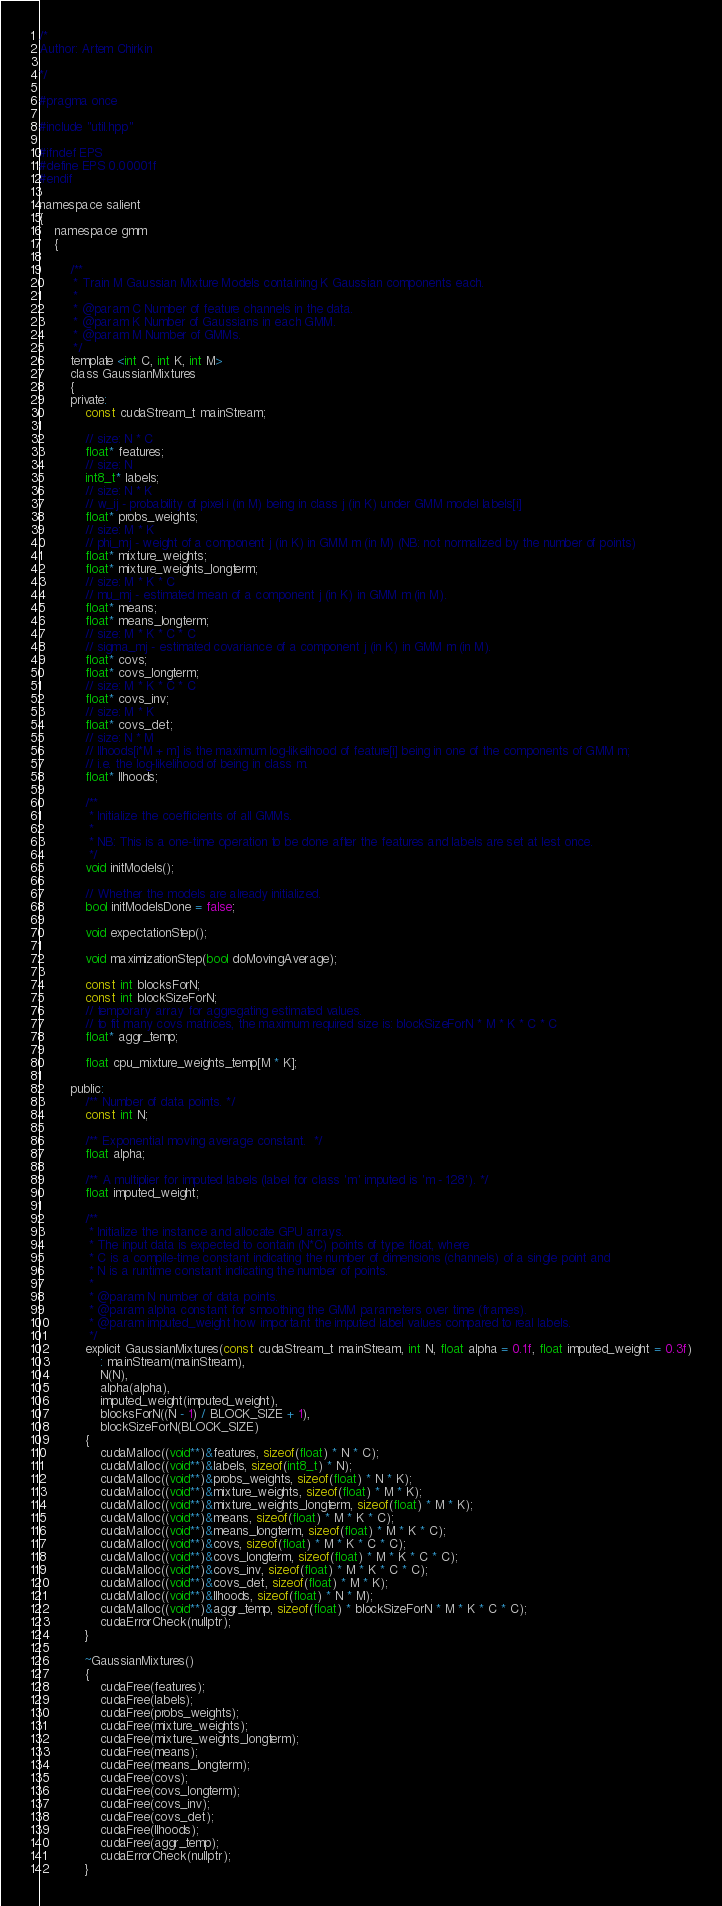<code> <loc_0><loc_0><loc_500><loc_500><_Cuda_>/*
Author: Artem Chirkin

*/

#pragma once

#include "util.hpp"

#ifndef EPS
#define EPS 0.00001f
#endif

namespace salient
{
    namespace gmm
    {

        /**
         * Train M Gaussian Mixture Models containing K Gaussian components each.
         *
         * @param C Number of feature channels in the data.
         * @param K Number of Gaussians in each GMM.
         * @param M Number of GMMs.
         */
        template <int C, int K, int M>
        class GaussianMixtures
        {
        private:
            const cudaStream_t mainStream;

            // size: N * C
            float* features;
            // size: N
            int8_t* labels;
            // size: N * K
            // w_ij - probability of pixel i (in M) being in class j (in K) under GMM model labels[i]
            float* probs_weights;
            // size: M * K
            // phi_mj - weight of a component j (in K) in GMM m (in M) (NB: not normalized by the number of points)
            float* mixture_weights;
            float* mixture_weights_longterm;
            // size: M * K * C
            // mu_mj - estimated mean of a component j (in K) in GMM m (in M).
            float* means;
            float* means_longterm;
            // size: M * K * C * C
            // sigma_mj - estimated covariance of a component j (in K) in GMM m (in M).
            float* covs;
            float* covs_longterm;
            // size: M * K * C * C
            float* covs_inv;
            // size: M * K
            float* covs_det;
            // size: N * M
            // llhoods[i*M + m] is the maximum log-likelihood of feature[i] being in one of the components of GMM m;
            // i.e. the log-likelihood of being in class m.
            float* llhoods;

            /**
             * Initialize the coefficients of all GMMs.
             *
             * NB: This is a one-time operation to be done after the features and labels are set at lest once.
             */
            void initModels();

            // Whether the models are already initialized.
            bool initModelsDone = false;

            void expectationStep();

            void maximizationStep(bool doMovingAverage);

            const int blocksForN;
            const int blockSizeForN;
            // temporary array for aggregating estimated values.
            // to fit many covs matrices, the maximum required size is: blockSizeForN * M * K * C * C
            float* aggr_temp;

            float cpu_mixture_weights_temp[M * K];

        public:
            /** Number of data points. */
            const int N;

            /** Exponential moving average constant.  */
            float alpha;

            /** A multiplier for imputed labels (label for class 'm' imputed is 'm - 128'). */
            float imputed_weight;

            /**
             * Initialize the instance and allocate GPU arrays.
             * The input data is expected to contain (N*C) points of type float, where
             * C is a compile-time constant indicating the number of dimensions (channels) of a single point and
             * N is a runtime constant indicating the number of points.
             *
             * @param N number of data points.
             * @param alpha constant for smoothing the GMM parameters over time (frames).
             * @param imputed_weight how important the imputed label values compared to real labels.
             */
            explicit GaussianMixtures(const cudaStream_t mainStream, int N, float alpha = 0.1f, float imputed_weight = 0.3f)
                : mainStream(mainStream),
                N(N),
                alpha(alpha),
                imputed_weight(imputed_weight),
                blocksForN((N - 1) / BLOCK_SIZE + 1),
                blockSizeForN(BLOCK_SIZE)
            {
                cudaMalloc((void**)&features, sizeof(float) * N * C);
                cudaMalloc((void**)&labels, sizeof(int8_t) * N);
                cudaMalloc((void**)&probs_weights, sizeof(float) * N * K);
                cudaMalloc((void**)&mixture_weights, sizeof(float) * M * K);
                cudaMalloc((void**)&mixture_weights_longterm, sizeof(float) * M * K);
                cudaMalloc((void**)&means, sizeof(float) * M * K * C);
                cudaMalloc((void**)&means_longterm, sizeof(float) * M * K * C);
                cudaMalloc((void**)&covs, sizeof(float) * M * K * C * C);
                cudaMalloc((void**)&covs_longterm, sizeof(float) * M * K * C * C);
                cudaMalloc((void**)&covs_inv, sizeof(float) * M * K * C * C);
                cudaMalloc((void**)&covs_det, sizeof(float) * M * K);
                cudaMalloc((void**)&llhoods, sizeof(float) * N * M);
                cudaMalloc((void**)&aggr_temp, sizeof(float) * blockSizeForN * M * K * C * C);
                cudaErrorCheck(nullptr);
            }

            ~GaussianMixtures()
            {
                cudaFree(features);
                cudaFree(labels);
                cudaFree(probs_weights);
                cudaFree(mixture_weights);
                cudaFree(mixture_weights_longterm);
                cudaFree(means);
                cudaFree(means_longterm);
                cudaFree(covs);
                cudaFree(covs_longterm);
                cudaFree(covs_inv);
                cudaFree(covs_det);
                cudaFree(llhoods);
                cudaFree(aggr_temp);
                cudaErrorCheck(nullptr);
            }
</code> 